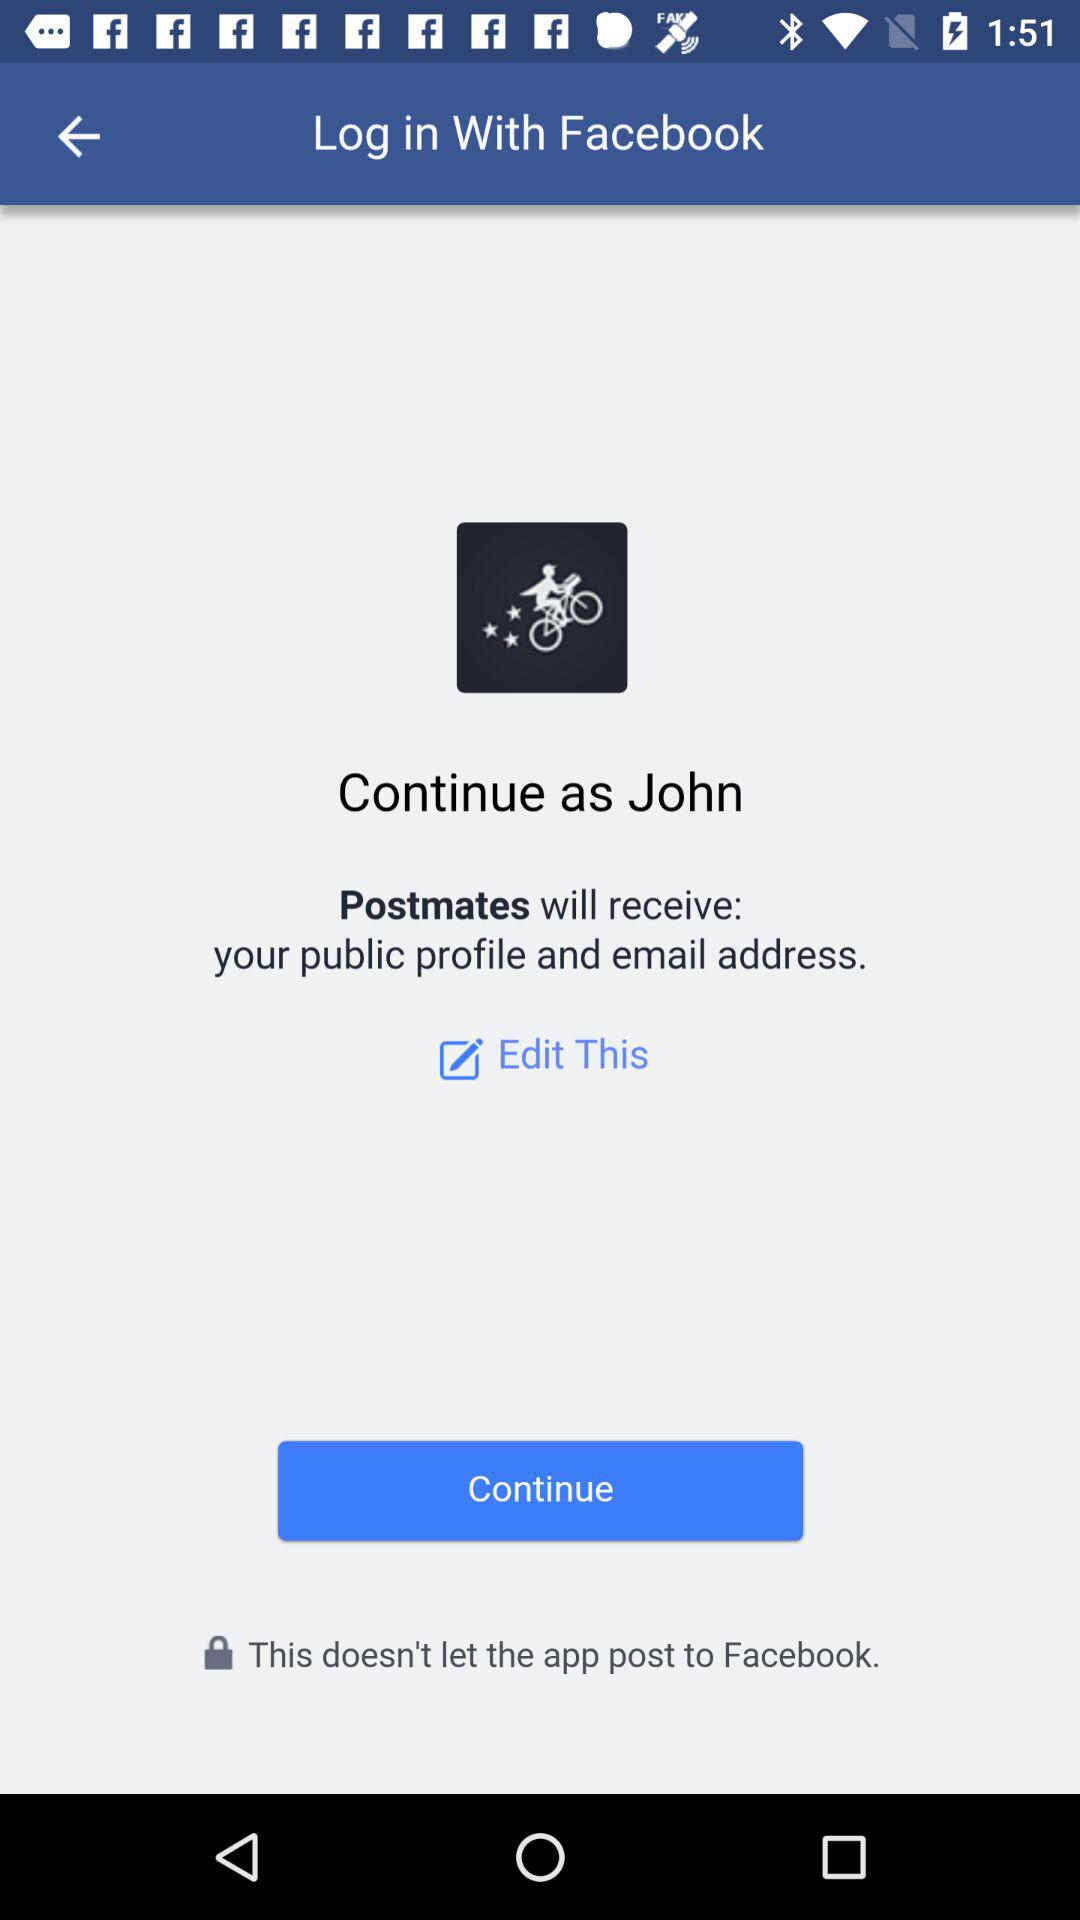Who will receive the public profile and email address? The public profile and email address will be received by "Postmates". 